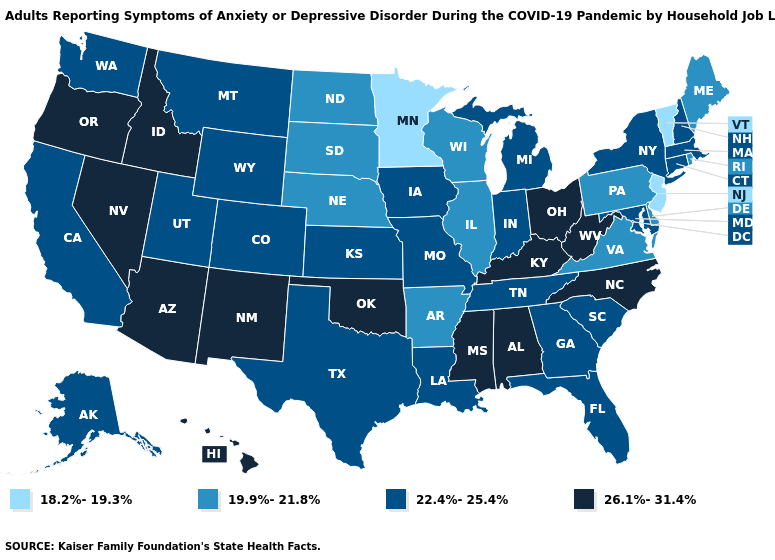Name the states that have a value in the range 26.1%-31.4%?
Give a very brief answer. Alabama, Arizona, Hawaii, Idaho, Kentucky, Mississippi, Nevada, New Mexico, North Carolina, Ohio, Oklahoma, Oregon, West Virginia. Name the states that have a value in the range 22.4%-25.4%?
Concise answer only. Alaska, California, Colorado, Connecticut, Florida, Georgia, Indiana, Iowa, Kansas, Louisiana, Maryland, Massachusetts, Michigan, Missouri, Montana, New Hampshire, New York, South Carolina, Tennessee, Texas, Utah, Washington, Wyoming. Which states have the lowest value in the MidWest?
Answer briefly. Minnesota. Is the legend a continuous bar?
Concise answer only. No. What is the lowest value in the USA?
Give a very brief answer. 18.2%-19.3%. Does Rhode Island have the highest value in the USA?
Give a very brief answer. No. What is the value of Washington?
Keep it brief. 22.4%-25.4%. Name the states that have a value in the range 19.9%-21.8%?
Give a very brief answer. Arkansas, Delaware, Illinois, Maine, Nebraska, North Dakota, Pennsylvania, Rhode Island, South Dakota, Virginia, Wisconsin. What is the highest value in the MidWest ?
Short answer required. 26.1%-31.4%. Among the states that border Georgia , does South Carolina have the highest value?
Give a very brief answer. No. Does Rhode Island have the highest value in the Northeast?
Concise answer only. No. Does the first symbol in the legend represent the smallest category?
Concise answer only. Yes. Does Oklahoma have the lowest value in the South?
Quick response, please. No. Which states have the lowest value in the MidWest?
Write a very short answer. Minnesota. What is the lowest value in the West?
Keep it brief. 22.4%-25.4%. 